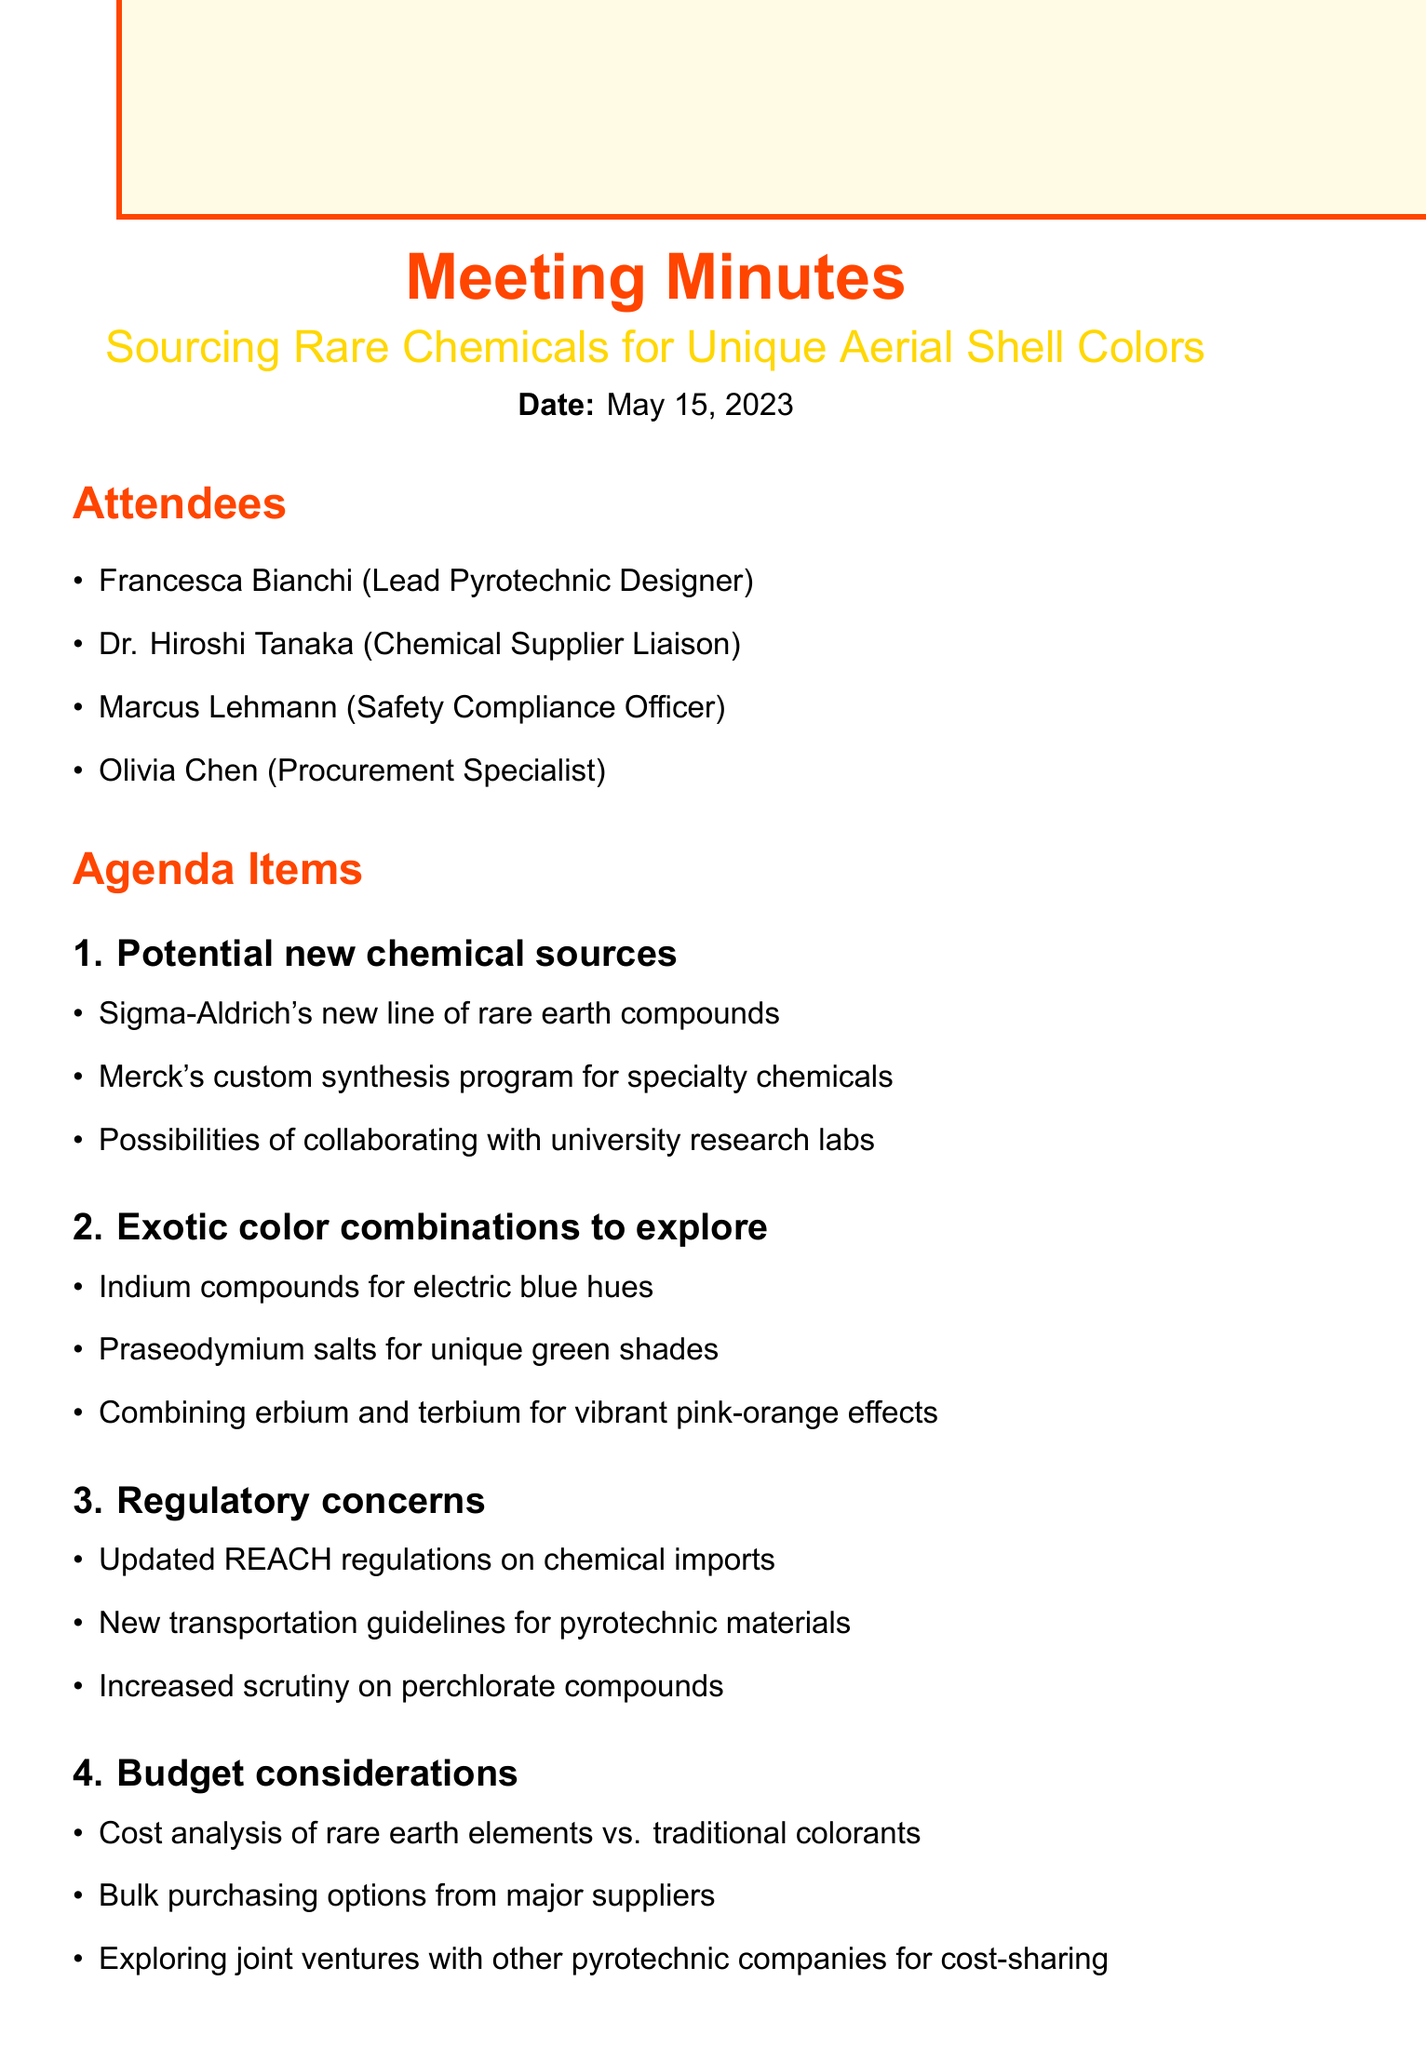What is the meeting title? The meeting title is the main focus of the discussion, which is mentioned at the top of the document.
Answer: Sourcing Rare Chemicals for Unique Aerial Shell Colors Who is the Lead Pyrotechnic Designer? The Lead Pyrotechnic Designer's name is listed in the attendees section of the document.
Answer: Francesca Bianchi What are the exotic color combinations discussed? This information is provided in one of the agenda items and lists specific compounds for color effects.
Answer: Indium compounds, Praseodymium salts, erbium and terbium What regulatory updates were mentioned? Regulatory concerns are listed under one of the agenda topics, detailing specific updates.
Answer: REACH regulations on chemical imports When is the next meeting scheduled? The date of the next meeting is noted in the conclusion of the document.
Answer: June 1, 2023 Who is responsible for requesting samples of new indium compounds? This responsibility is outlined as an action item, indicating who will take care of this task.
Answer: Dr. Tanaka What budget consideration involves joint ventures? The discussion about exploring joint ventures for cost-sharing falls under the budget considerations in the agenda.
Answer: joint ventures Which compounds are being tested for deep crimson effects? This inquiry pertains to the research and development priorities laid out in the document.
Answer: strontium-barium combinations 